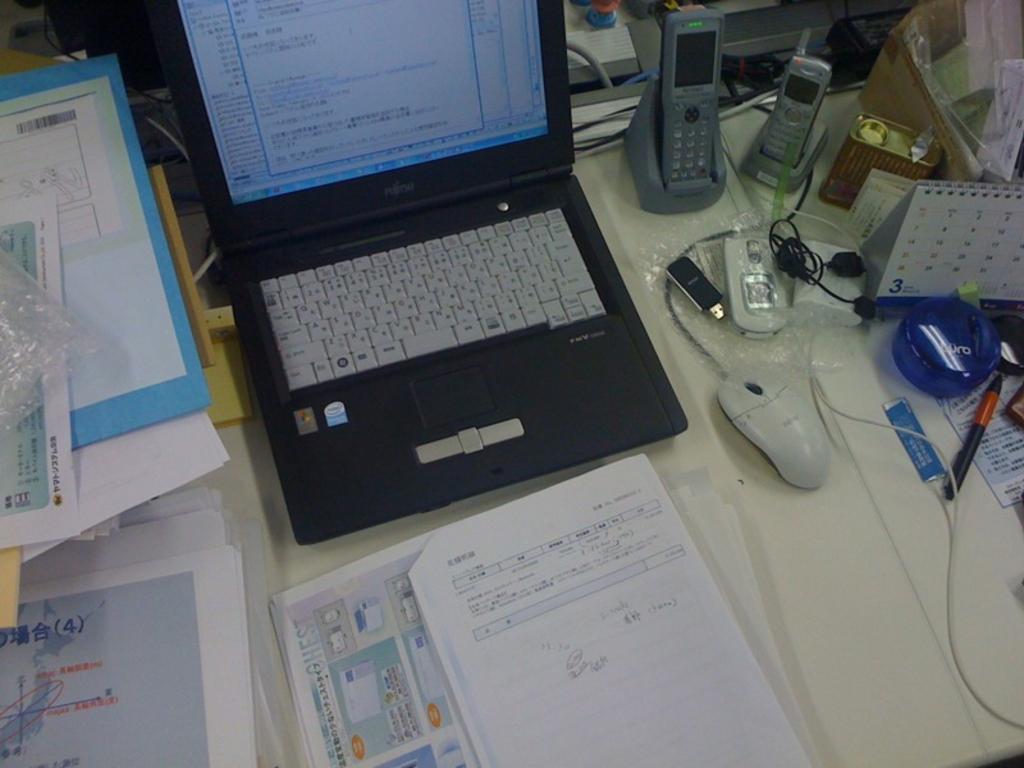<image>
Describe the image concisely. A calendar on the right of a laptop with the number 3 at the bottom left of it. 